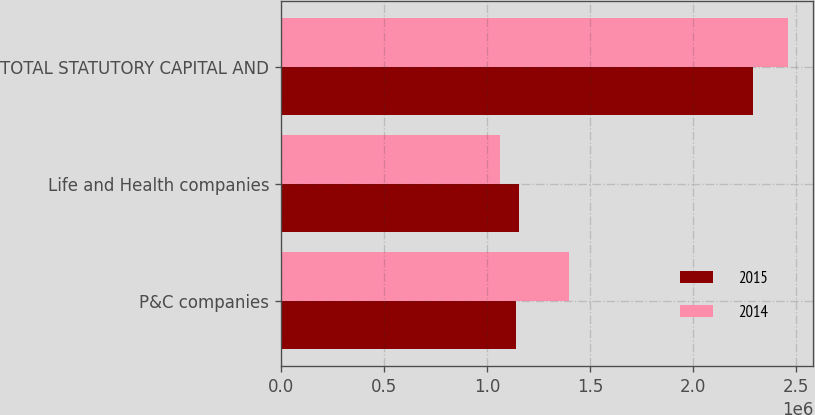Convert chart to OTSL. <chart><loc_0><loc_0><loc_500><loc_500><stacked_bar_chart><ecel><fcel>P&C companies<fcel>Life and Health companies<fcel>TOTAL STATUTORY CAPITAL AND<nl><fcel>2015<fcel>1.13798e+06<fcel>1.15314e+06<fcel>2.29112e+06<nl><fcel>2014<fcel>1.3963e+06<fcel>1.06417e+06<fcel>2.46048e+06<nl></chart> 